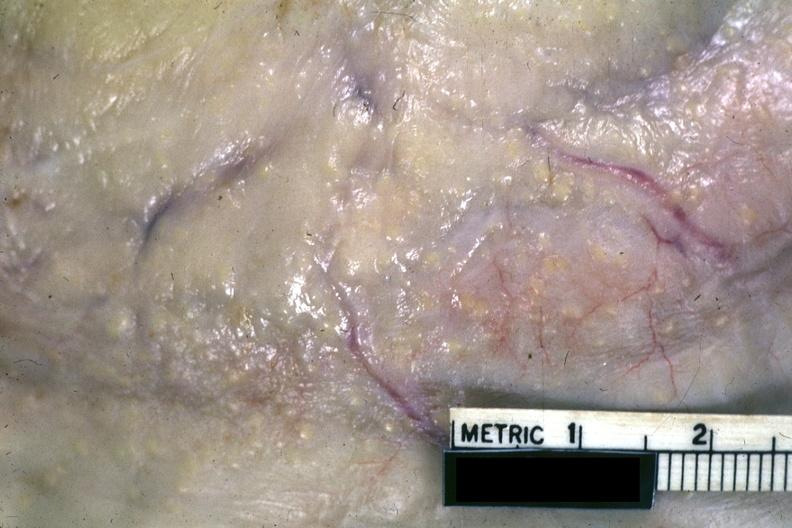what is present?
Answer the question using a single word or phrase. Abdomen 